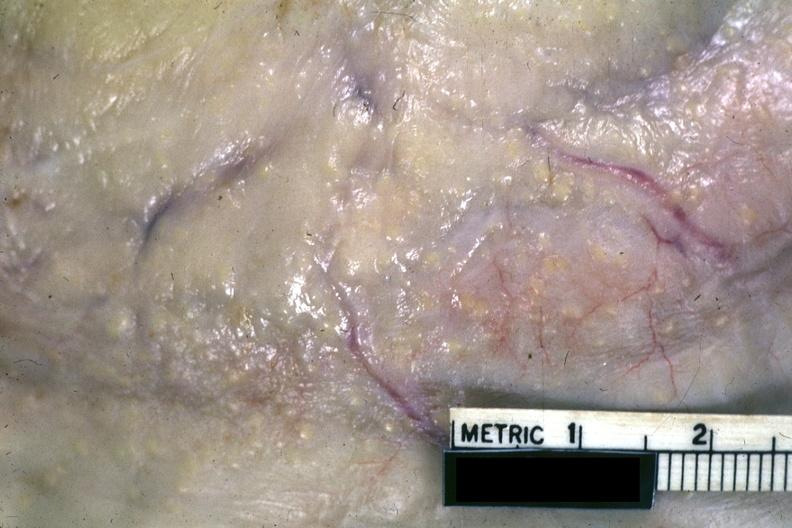what is present?
Answer the question using a single word or phrase. Abdomen 